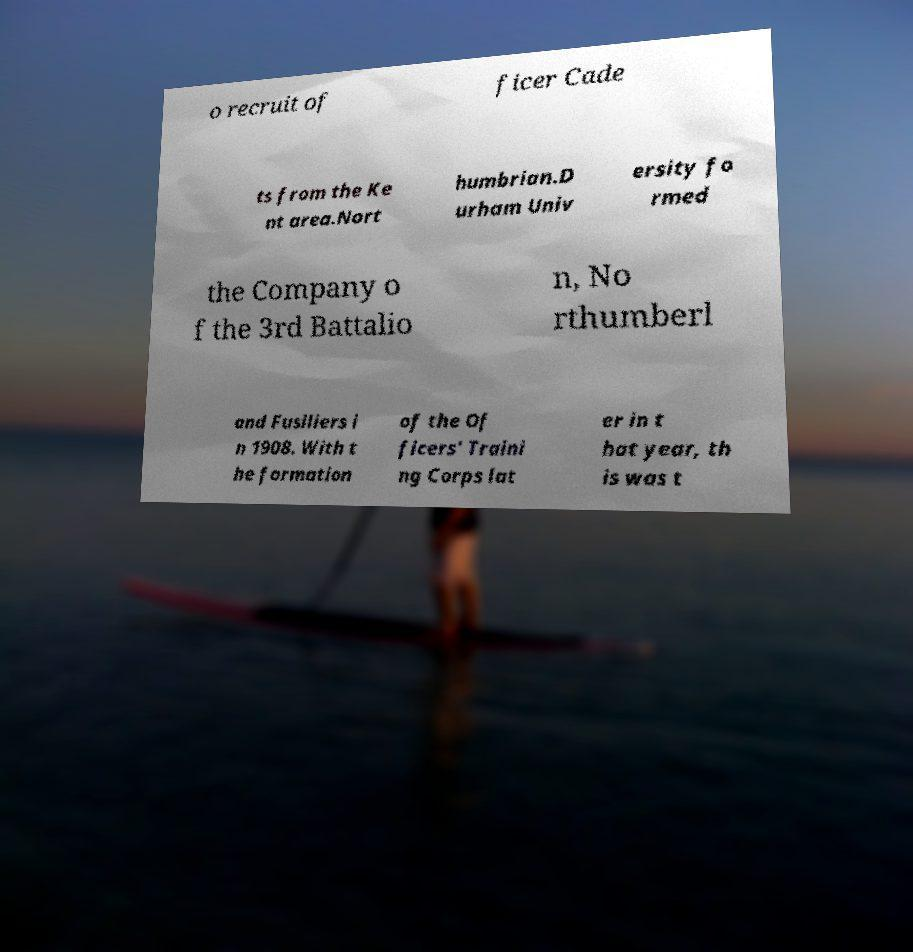Please read and relay the text visible in this image. What does it say? o recruit of ficer Cade ts from the Ke nt area.Nort humbrian.D urham Univ ersity fo rmed the Company o f the 3rd Battalio n, No rthumberl and Fusiliers i n 1908. With t he formation of the Of ficers' Traini ng Corps lat er in t hat year, th is was t 